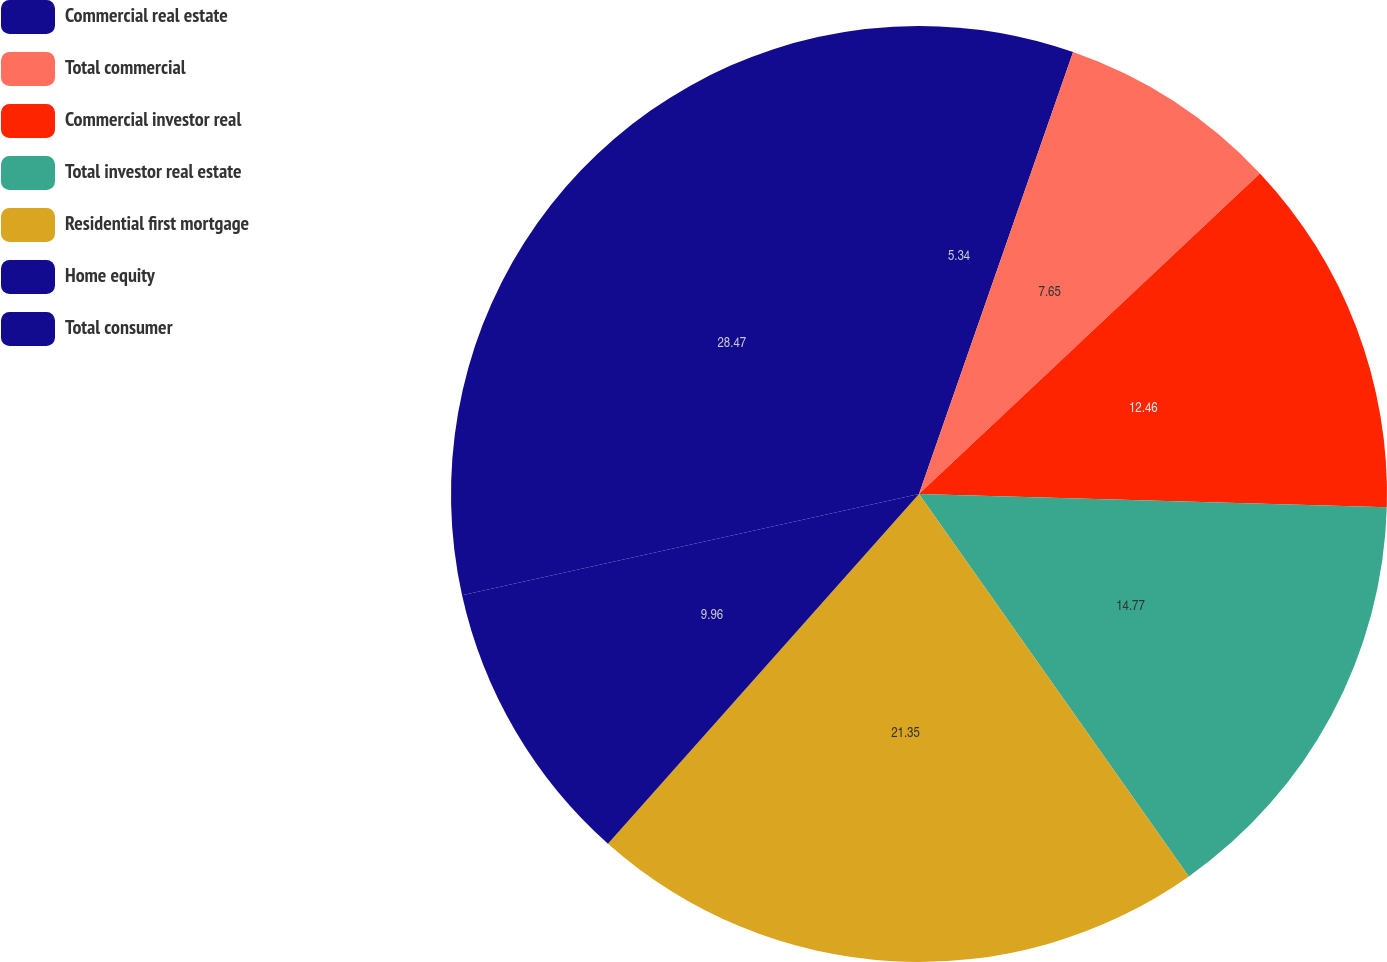Convert chart. <chart><loc_0><loc_0><loc_500><loc_500><pie_chart><fcel>Commercial real estate<fcel>Total commercial<fcel>Commercial investor real<fcel>Total investor real estate<fcel>Residential first mortgage<fcel>Home equity<fcel>Total consumer<nl><fcel>5.34%<fcel>7.65%<fcel>12.46%<fcel>14.77%<fcel>21.35%<fcel>9.96%<fcel>28.47%<nl></chart> 